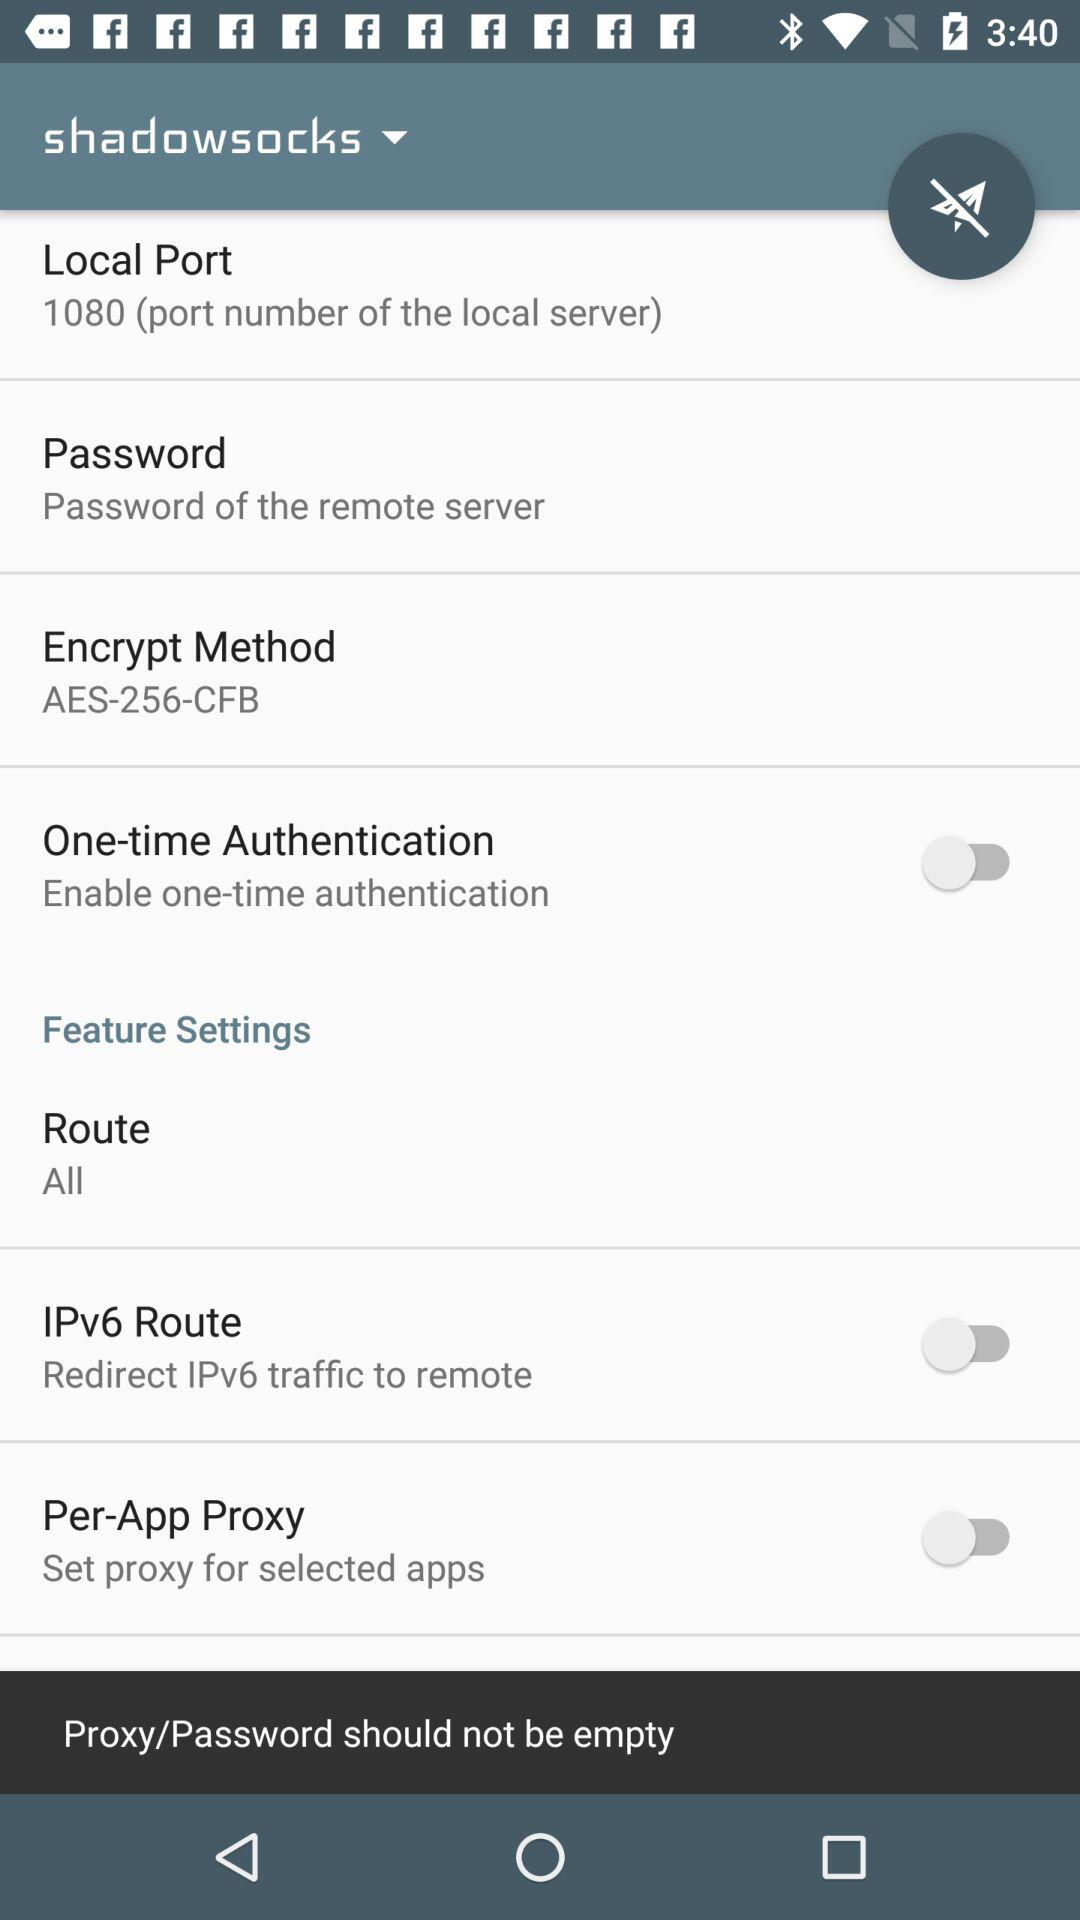How many items have a switch in the feature settings section?
Answer the question using a single word or phrase. 2 